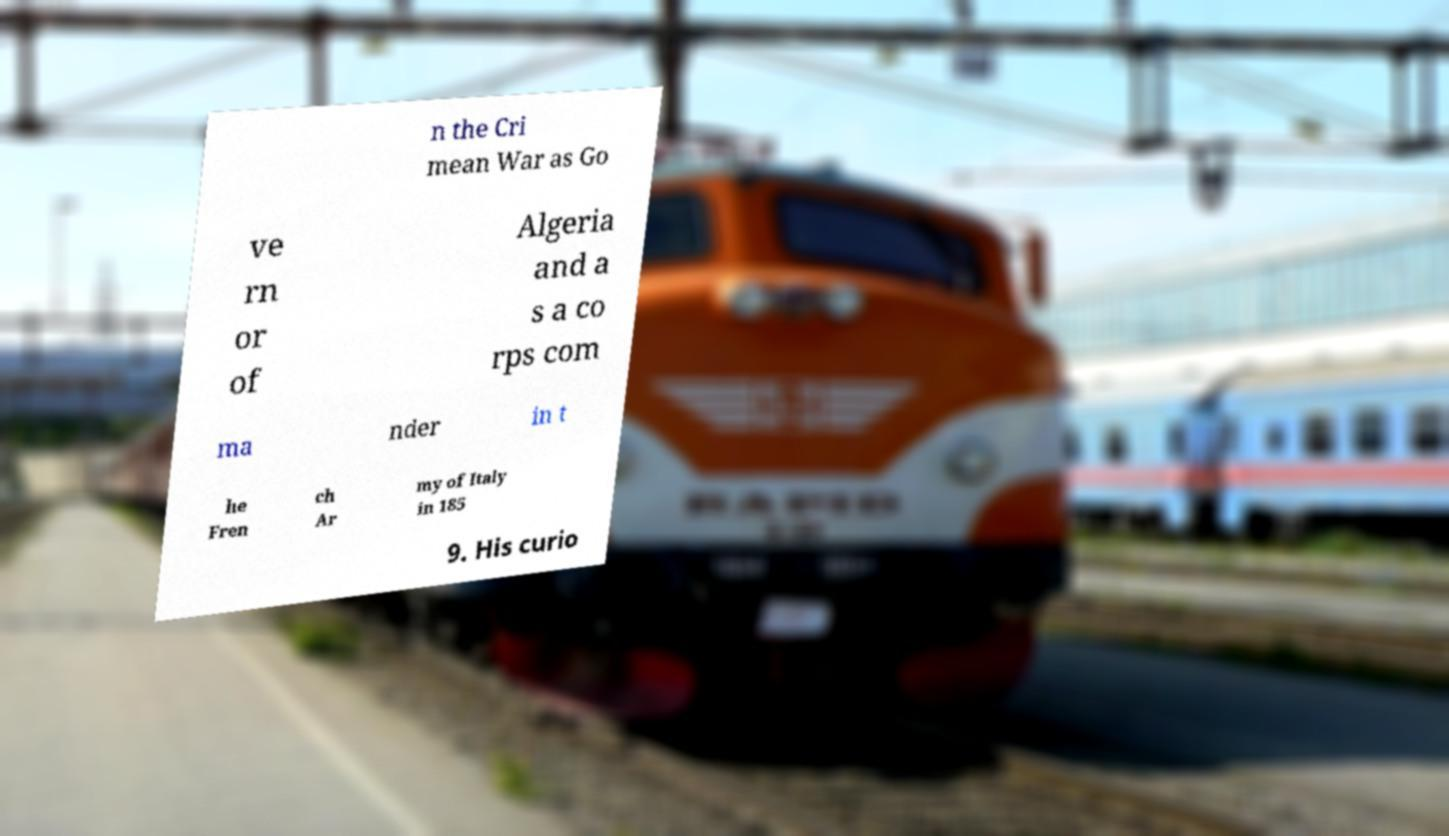Can you accurately transcribe the text from the provided image for me? n the Cri mean War as Go ve rn or of Algeria and a s a co rps com ma nder in t he Fren ch Ar my of Italy in 185 9. His curio 